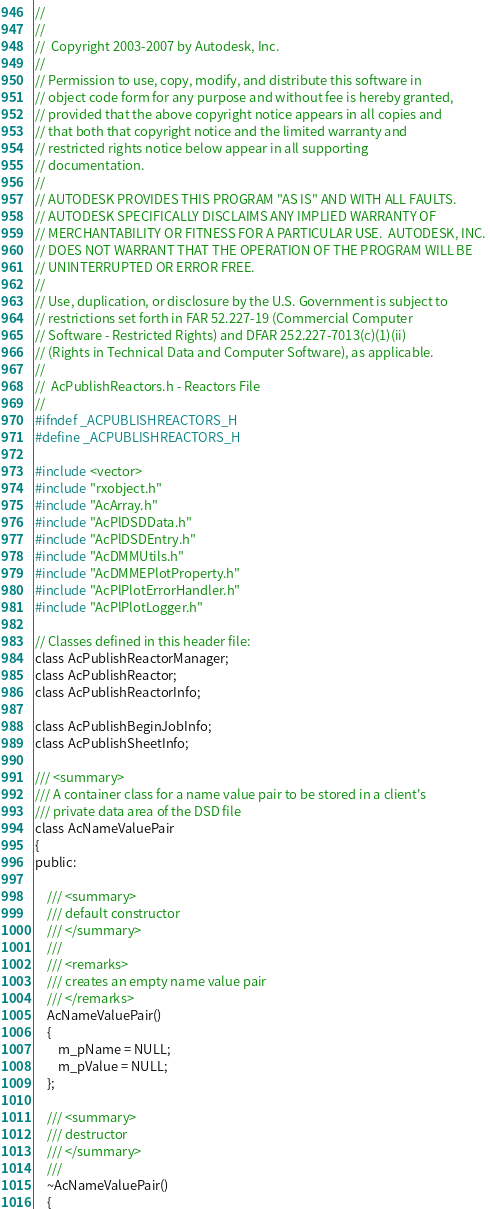<code> <loc_0><loc_0><loc_500><loc_500><_C_>//
//
//  Copyright 2003-2007 by Autodesk, Inc.
//
// Permission to use, copy, modify, and distribute this software in
// object code form for any purpose and without fee is hereby granted, 
// provided that the above copyright notice appears in all copies and 
// that both that copyright notice and the limited warranty and
// restricted rights notice below appear in all supporting 
// documentation.
//
// AUTODESK PROVIDES THIS PROGRAM "AS IS" AND WITH ALL FAULTS. 
// AUTODESK SPECIFICALLY DISCLAIMS ANY IMPLIED WARRANTY OF
// MERCHANTABILITY OR FITNESS FOR A PARTICULAR USE.  AUTODESK, INC. 
// DOES NOT WARRANT THAT THE OPERATION OF THE PROGRAM WILL BE
// UNINTERRUPTED OR ERROR FREE.
//
// Use, duplication, or disclosure by the U.S. Government is subject to 
// restrictions set forth in FAR 52.227-19 (Commercial Computer
// Software - Restricted Rights) and DFAR 252.227-7013(c)(1)(ii)
// (Rights in Technical Data and Computer Software), as applicable.
//
//  AcPublishReactors.h - Reactors File
//
#ifndef _ACPUBLISHREACTORS_H
#define _ACPUBLISHREACTORS_H

#include <vector>
#include "rxobject.h"
#include "AcArray.h"
#include "AcPlDSDData.h"
#include "AcPlDSDEntry.h"
#include "AcDMMUtils.h"
#include "AcDMMEPlotProperty.h"
#include "AcPlPlotErrorHandler.h"
#include "AcPlPlotLogger.h"

// Classes defined in this header file:
class AcPublishReactorManager;
class AcPublishReactor;
class AcPublishReactorInfo;

class AcPublishBeginJobInfo;
class AcPublishSheetInfo;

/// <summary>
/// A container class for a name value pair to be stored in a client's
/// private data area of the DSD file
class AcNameValuePair
{
public:

    /// <summary>
    /// default constructor
    /// </summary>
    ///
    /// <remarks>
    /// creates an empty name value pair
    /// </remarks>
    AcNameValuePair() 
    {
        m_pName = NULL;
        m_pValue = NULL;
    };

    /// <summary>
    /// destructor
    /// </summary>
    ///
    ~AcNameValuePair() 
    {</code> 